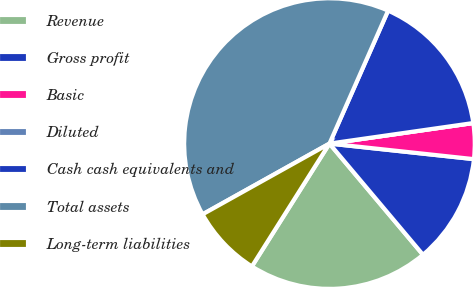Convert chart. <chart><loc_0><loc_0><loc_500><loc_500><pie_chart><fcel>Revenue<fcel>Gross profit<fcel>Basic<fcel>Diluted<fcel>Cash cash equivalents and<fcel>Total assets<fcel>Long-term liabilities<nl><fcel>20.1%<fcel>12.16%<fcel>3.97%<fcel>0.0%<fcel>16.13%<fcel>39.71%<fcel>7.94%<nl></chart> 